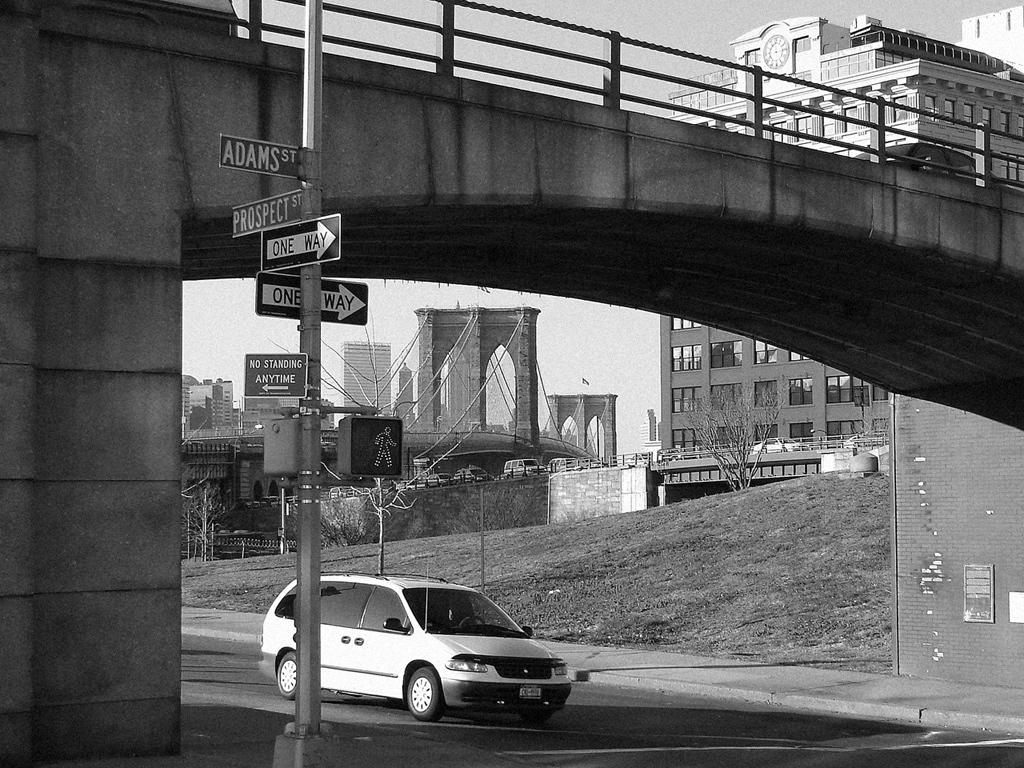<image>
Provide a brief description of the given image. A car going underneath a bridge at the intersection of prospect and adams. 